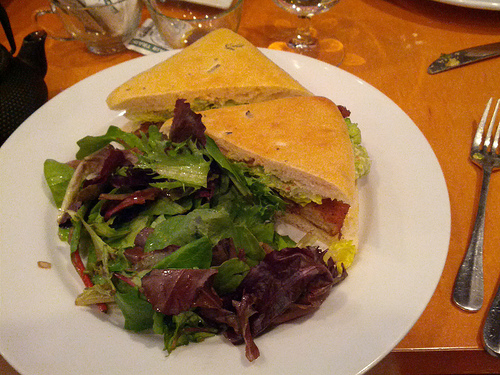Is the yellow food to the right or to the left of the fork? The yellow-hued bread of the sandwich is positioned to the left of the fork in this image. 